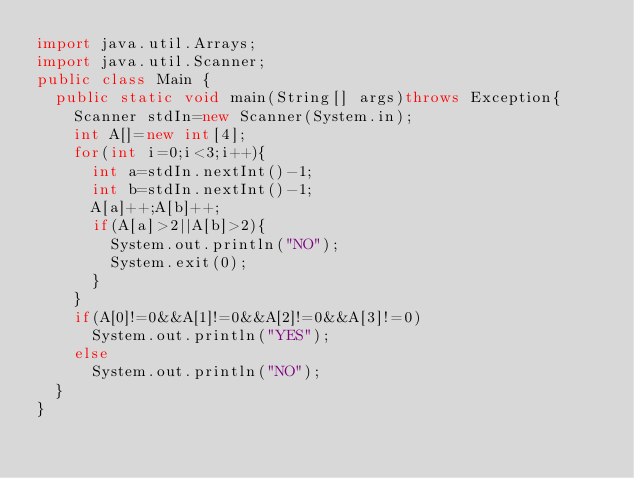Convert code to text. <code><loc_0><loc_0><loc_500><loc_500><_Java_>import java.util.Arrays;
import java.util.Scanner;
public class Main {
	public static void main(String[] args)throws Exception{
		Scanner stdIn=new Scanner(System.in);
		int A[]=new int[4];
		for(int i=0;i<3;i++){
			int a=stdIn.nextInt()-1;
			int b=stdIn.nextInt()-1;
			A[a]++;A[b]++;
			if(A[a]>2||A[b]>2){
				System.out.println("NO");
				System.exit(0);
			}
		}
		if(A[0]!=0&&A[1]!=0&&A[2]!=0&&A[3]!=0)
			System.out.println("YES");
		else
			System.out.println("NO");
	}
}
</code> 